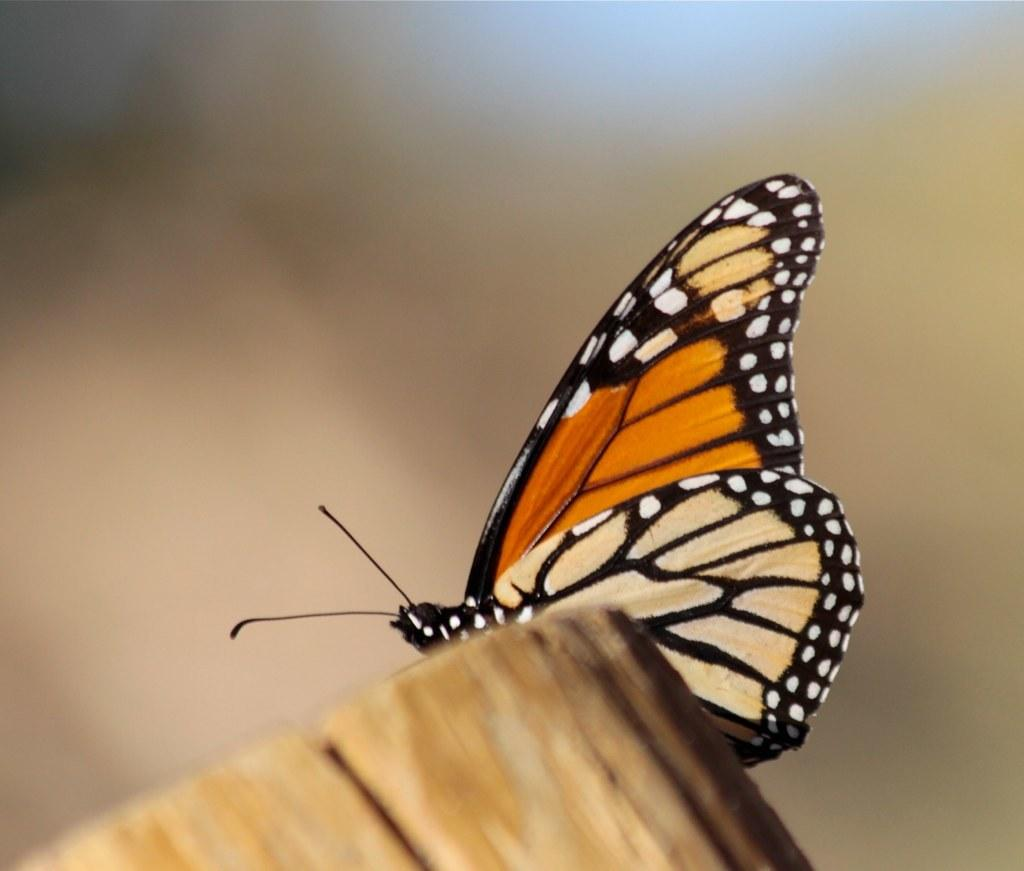What is the main subject of the image? There is a butterfly in the image. Where is the butterfly located? The butterfly is on a wooden log. What is the wooden log's position in the image? The wooden log is in the center of the image. What type of bread can be seen in the image? There is no bread present in the image. 